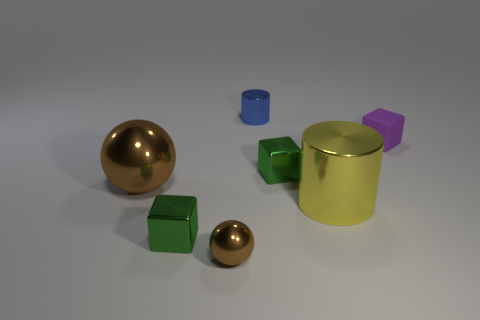If we consider the larger gold sphere as a sun, which objects might represent planets in this space? If the large gold sphere is imagined as the sun, the smaller gold sphere might represent a closer planet like Mercury. The green cube could be Earth, the yellow cylinder could be Saturn with its rings, and the purple cube might represent a distant planet like Neptune. The blue cylinder doesn't quite fit into the planetary theme but might be imagined as a passing spaceship or satellite. 